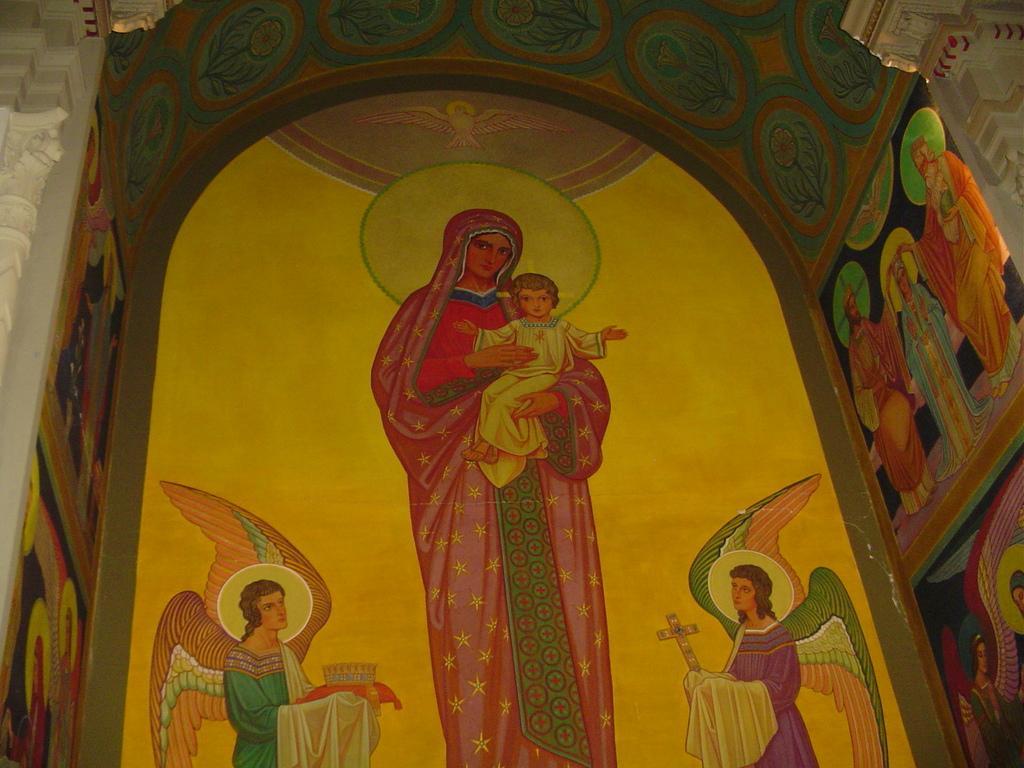Please provide a concise description of this image. Here we can see a painting of some people and a bird and there are pillars and an arch. 